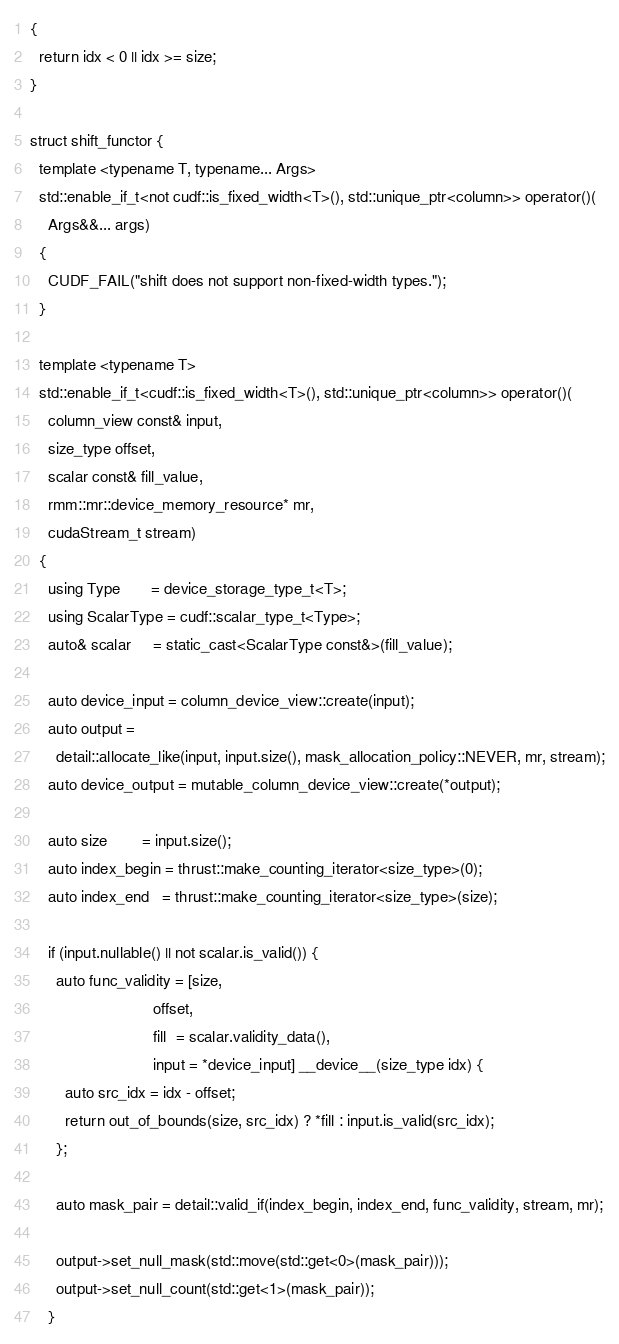<code> <loc_0><loc_0><loc_500><loc_500><_Cuda_>{
  return idx < 0 || idx >= size;
}

struct shift_functor {
  template <typename T, typename... Args>
  std::enable_if_t<not cudf::is_fixed_width<T>(), std::unique_ptr<column>> operator()(
    Args&&... args)
  {
    CUDF_FAIL("shift does not support non-fixed-width types.");
  }

  template <typename T>
  std::enable_if_t<cudf::is_fixed_width<T>(), std::unique_ptr<column>> operator()(
    column_view const& input,
    size_type offset,
    scalar const& fill_value,
    rmm::mr::device_memory_resource* mr,
    cudaStream_t stream)
  {
    using Type       = device_storage_type_t<T>;
    using ScalarType = cudf::scalar_type_t<Type>;
    auto& scalar     = static_cast<ScalarType const&>(fill_value);

    auto device_input = column_device_view::create(input);
    auto output =
      detail::allocate_like(input, input.size(), mask_allocation_policy::NEVER, mr, stream);
    auto device_output = mutable_column_device_view::create(*output);

    auto size        = input.size();
    auto index_begin = thrust::make_counting_iterator<size_type>(0);
    auto index_end   = thrust::make_counting_iterator<size_type>(size);

    if (input.nullable() || not scalar.is_valid()) {
      auto func_validity = [size,
                            offset,
                            fill  = scalar.validity_data(),
                            input = *device_input] __device__(size_type idx) {
        auto src_idx = idx - offset;
        return out_of_bounds(size, src_idx) ? *fill : input.is_valid(src_idx);
      };

      auto mask_pair = detail::valid_if(index_begin, index_end, func_validity, stream, mr);

      output->set_null_mask(std::move(std::get<0>(mask_pair)));
      output->set_null_count(std::get<1>(mask_pair));
    }
</code> 